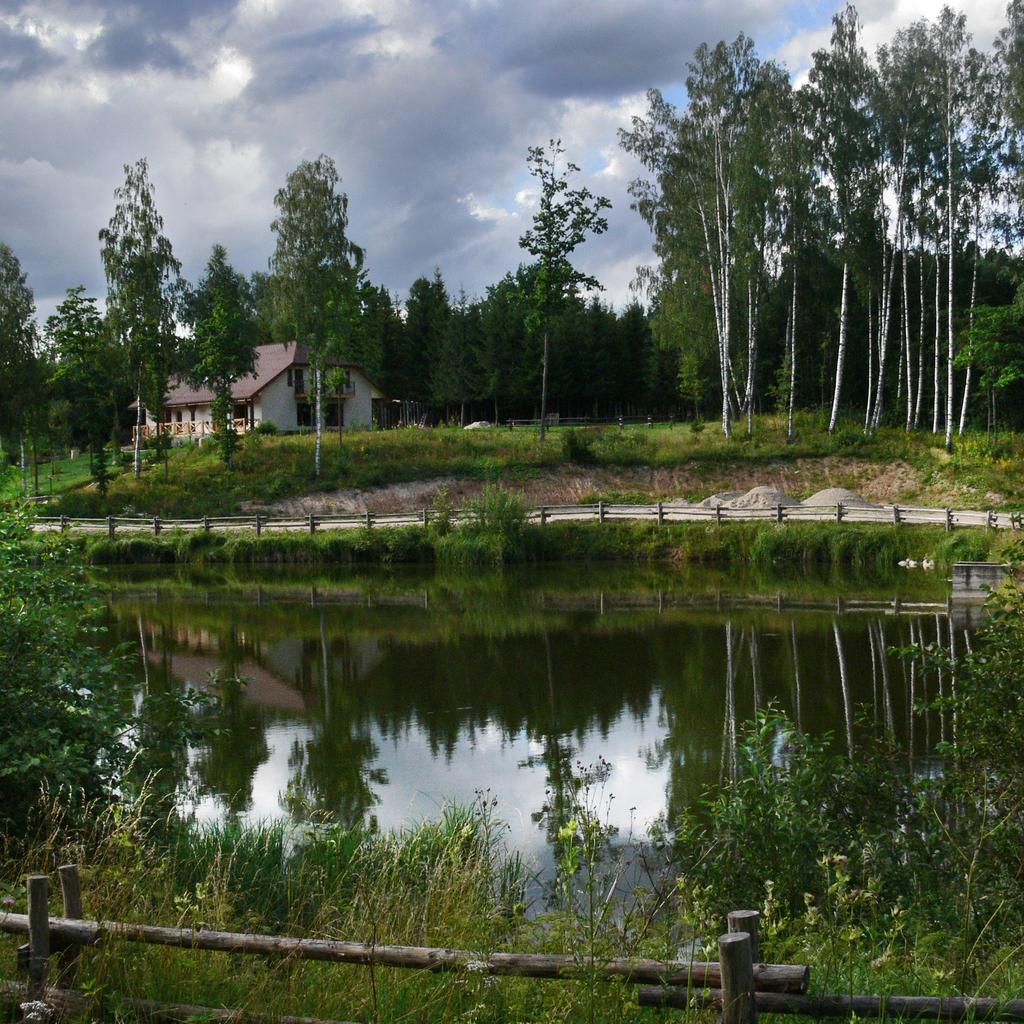What type of vegetation can be seen in the image? There are plants in the image. What is located behind the plants? There is a canal behind the plants. What can be seen in the background of the image? There is a path, trees, a house, and the sky visible in the background. What type of breakfast is being served on the sponge in the image? There is no sponge or breakfast present in the image. 